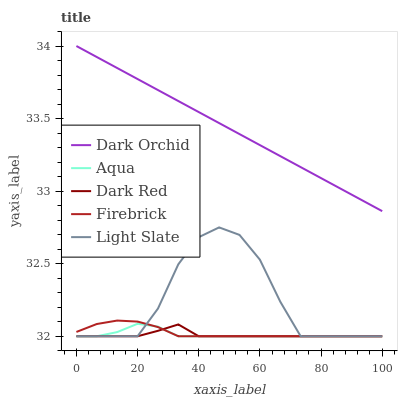Does Dark Red have the minimum area under the curve?
Answer yes or no. Yes. Does Dark Orchid have the maximum area under the curve?
Answer yes or no. Yes. Does Firebrick have the minimum area under the curve?
Answer yes or no. No. Does Firebrick have the maximum area under the curve?
Answer yes or no. No. Is Dark Orchid the smoothest?
Answer yes or no. Yes. Is Light Slate the roughest?
Answer yes or no. Yes. Is Dark Red the smoothest?
Answer yes or no. No. Is Dark Red the roughest?
Answer yes or no. No. Does Light Slate have the lowest value?
Answer yes or no. Yes. Does Dark Orchid have the lowest value?
Answer yes or no. No. Does Dark Orchid have the highest value?
Answer yes or no. Yes. Does Firebrick have the highest value?
Answer yes or no. No. Is Aqua less than Dark Orchid?
Answer yes or no. Yes. Is Dark Orchid greater than Dark Red?
Answer yes or no. Yes. Does Dark Red intersect Light Slate?
Answer yes or no. Yes. Is Dark Red less than Light Slate?
Answer yes or no. No. Is Dark Red greater than Light Slate?
Answer yes or no. No. Does Aqua intersect Dark Orchid?
Answer yes or no. No. 